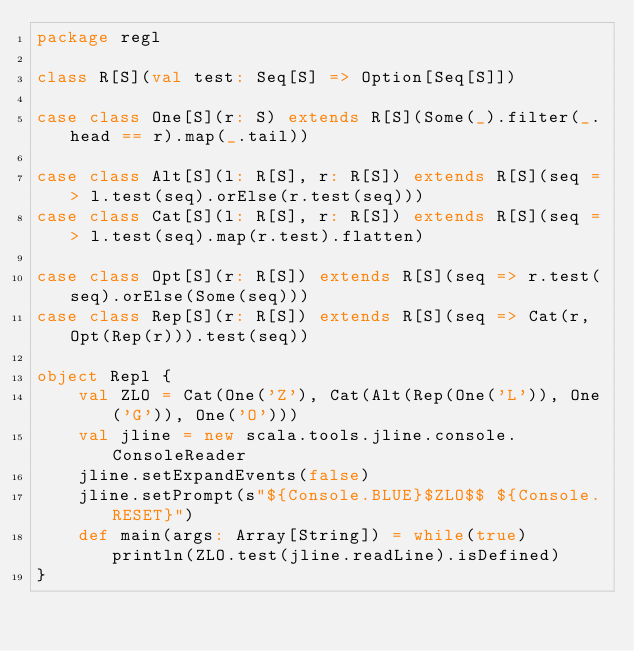Convert code to text. <code><loc_0><loc_0><loc_500><loc_500><_Scala_>package regl

class R[S](val test: Seq[S] => Option[Seq[S]])

case class One[S](r: S) extends R[S](Some(_).filter(_.head == r).map(_.tail))

case class Alt[S](l: R[S], r: R[S]) extends R[S](seq => l.test(seq).orElse(r.test(seq)))
case class Cat[S](l: R[S], r: R[S]) extends R[S](seq => l.test(seq).map(r.test).flatten)

case class Opt[S](r: R[S]) extends R[S](seq => r.test(seq).orElse(Some(seq)))
case class Rep[S](r: R[S]) extends R[S](seq => Cat(r, Opt(Rep(r))).test(seq))

object Repl {
	val ZLO = Cat(One('Z'), Cat(Alt(Rep(One('L')), One('G')), One('O')))
	val jline = new scala.tools.jline.console.ConsoleReader
	jline.setExpandEvents(false)
	jline.setPrompt(s"${Console.BLUE}$ZLO$$ ${Console.RESET}")
	def main(args: Array[String]) = while(true) println(ZLO.test(jline.readLine).isDefined)
}
</code> 